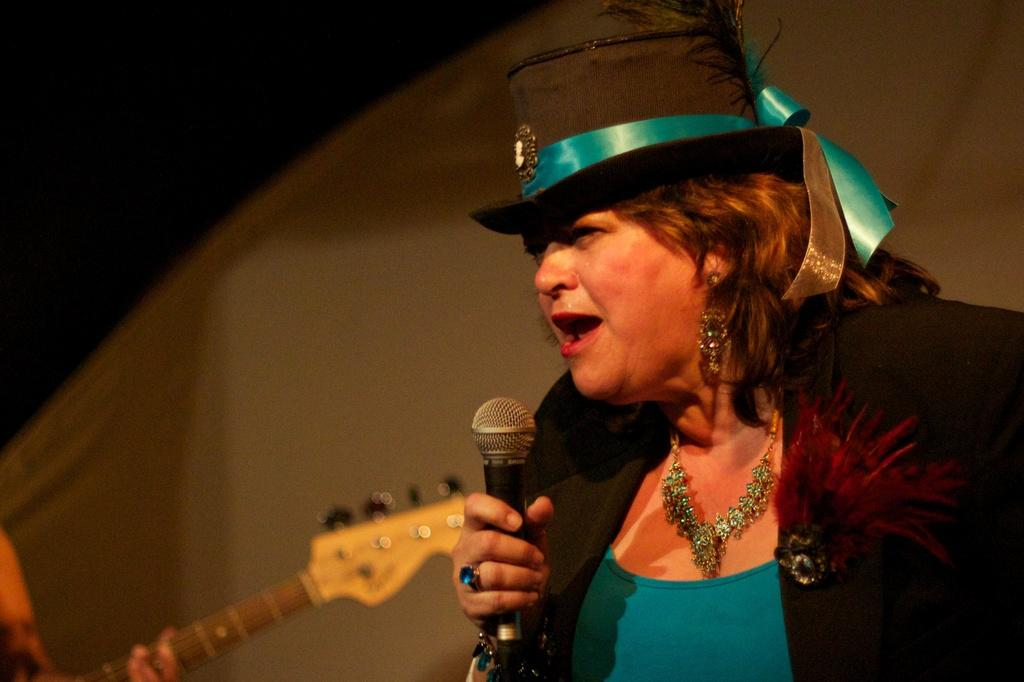Who is the main subject in the image? There is a woman in the image. What is the woman doing in the image? The woman is catching a microphone in her hand. Can you describe the woman's attire? The woman is wearing a cap, a necklace, an earring, and a black color blazer. What other object is visible in the image? There is a guitar visible in the image. How many doors can be seen in the image? There are no doors visible in the image; it features a woman catching a microphone and a guitar. What type of rings is the woman wearing in the image? There is no mention of rings in the provided facts, so we cannot determine if the woman is wearing any rings in the image. 